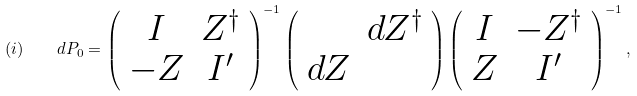Convert formula to latex. <formula><loc_0><loc_0><loc_500><loc_500>( i ) \quad d P _ { 0 } = \left ( \begin{array} { c c } I & Z ^ { \dag } \\ - Z & I ^ { \prime } \\ \end{array} \right ) ^ { - 1 } \left ( \begin{array} { c c } & d Z ^ { \dag } \\ d Z & \\ \end{array} \right ) \left ( \begin{array} { c c } I & - Z ^ { \dag } \\ Z & I ^ { \prime } \\ \end{array} \right ) ^ { - 1 } ,</formula> 